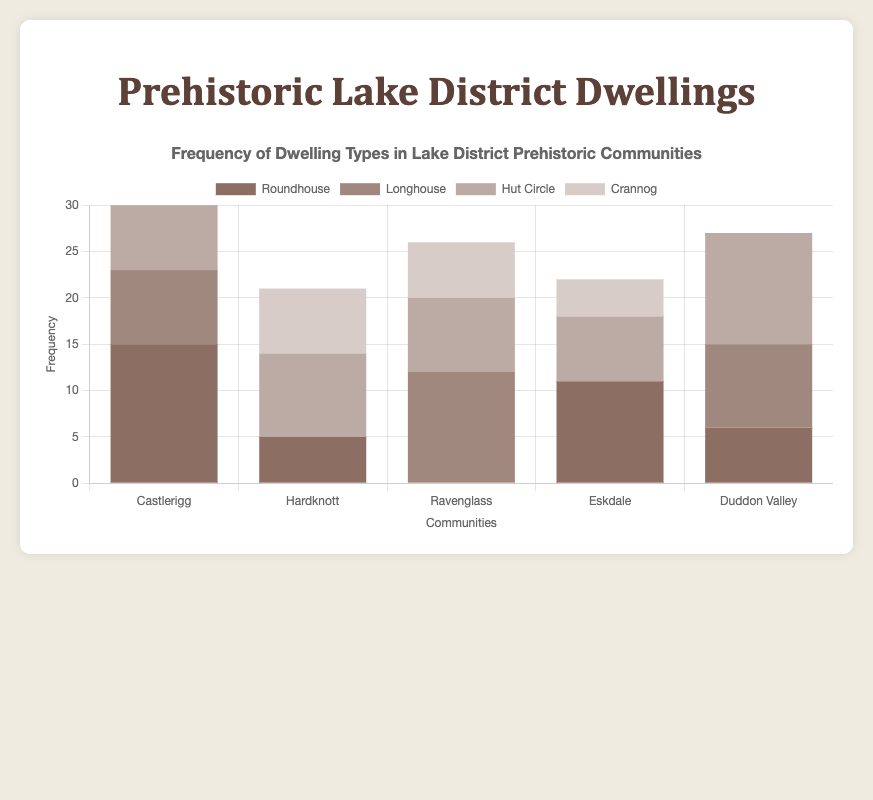Which community has the highest frequency of Roundhouse dwellings? Observing the heights of the bars labeled "Roundhouse" in each community, Castlerigg has the tallest bar for Roundhouses with a frequency of 15.
Answer: Castlerigg Which type of dwelling has the lowest frequency in Ravenglass? Looking at the bar segments for Ravenglass, Crannog dwellings have the smallest segment with a frequency of 6.
Answer: Crannog What is the total frequency of dwellings in Hardknott? Sum the frequencies of all dwelling types in Hardknott: 5 (Roundhouse) + 7 (Crannog) + 9 (Hut Circle) = 21.
Answer: 21 Which community has an equal frequency of Longhouse and Crannog dwellings? Observing the bar heights, Ravenglass has 12 Longhouse dwellings and 6 Crannog dwellings, and Duddon Valley has 9 for both. Therefore, Duddon Valley has equal frequencies for Longhouse and Crannog dwellings.
Answer: Duddon Valley What's the difference in the frequency of Hut Circle dwellings between Castlerigg and Duddon Valley? Hut Circle dwellings in Castlerigg are 10 and in Duddon Valley are 12. The difference is 12 - 10 = 2.
Answer: 2 Among all the communities, which type of dwelling shows the most consistent frequency? Observing the heights of the bars for each dwelling type across all communities, Hut Circle shows relatively consistent frequencies across all communities (ranging between 7 and 12).
Answer: Hut Circle What is the average frequency of Crannog dwellings across all communities? Sum the frequencies of Crannog dwellings for all communities: 7 (Hardknott) + 6 (Ravenglass) + 4 (Eskdale). Average = (7 + 6 + 4) / 3 = 17 / 3 ≈ 5.67.
Answer: 5.67 Which community has the greatest disparity in frequency between any two types of dwellings? Look for the community with the largest difference between the tallest and shortest bar segments. Castlerigg has 15 Roundhouse and 8 Longhouse dwellings, a disparity of 15 - 8 = 7. Ravenglass has 12 Longhouses and 6 Crannogs, a disparity of 12 - 6 = 6. The greatest disparity is in Castlerigg with 7.
Answer: Castlerigg 